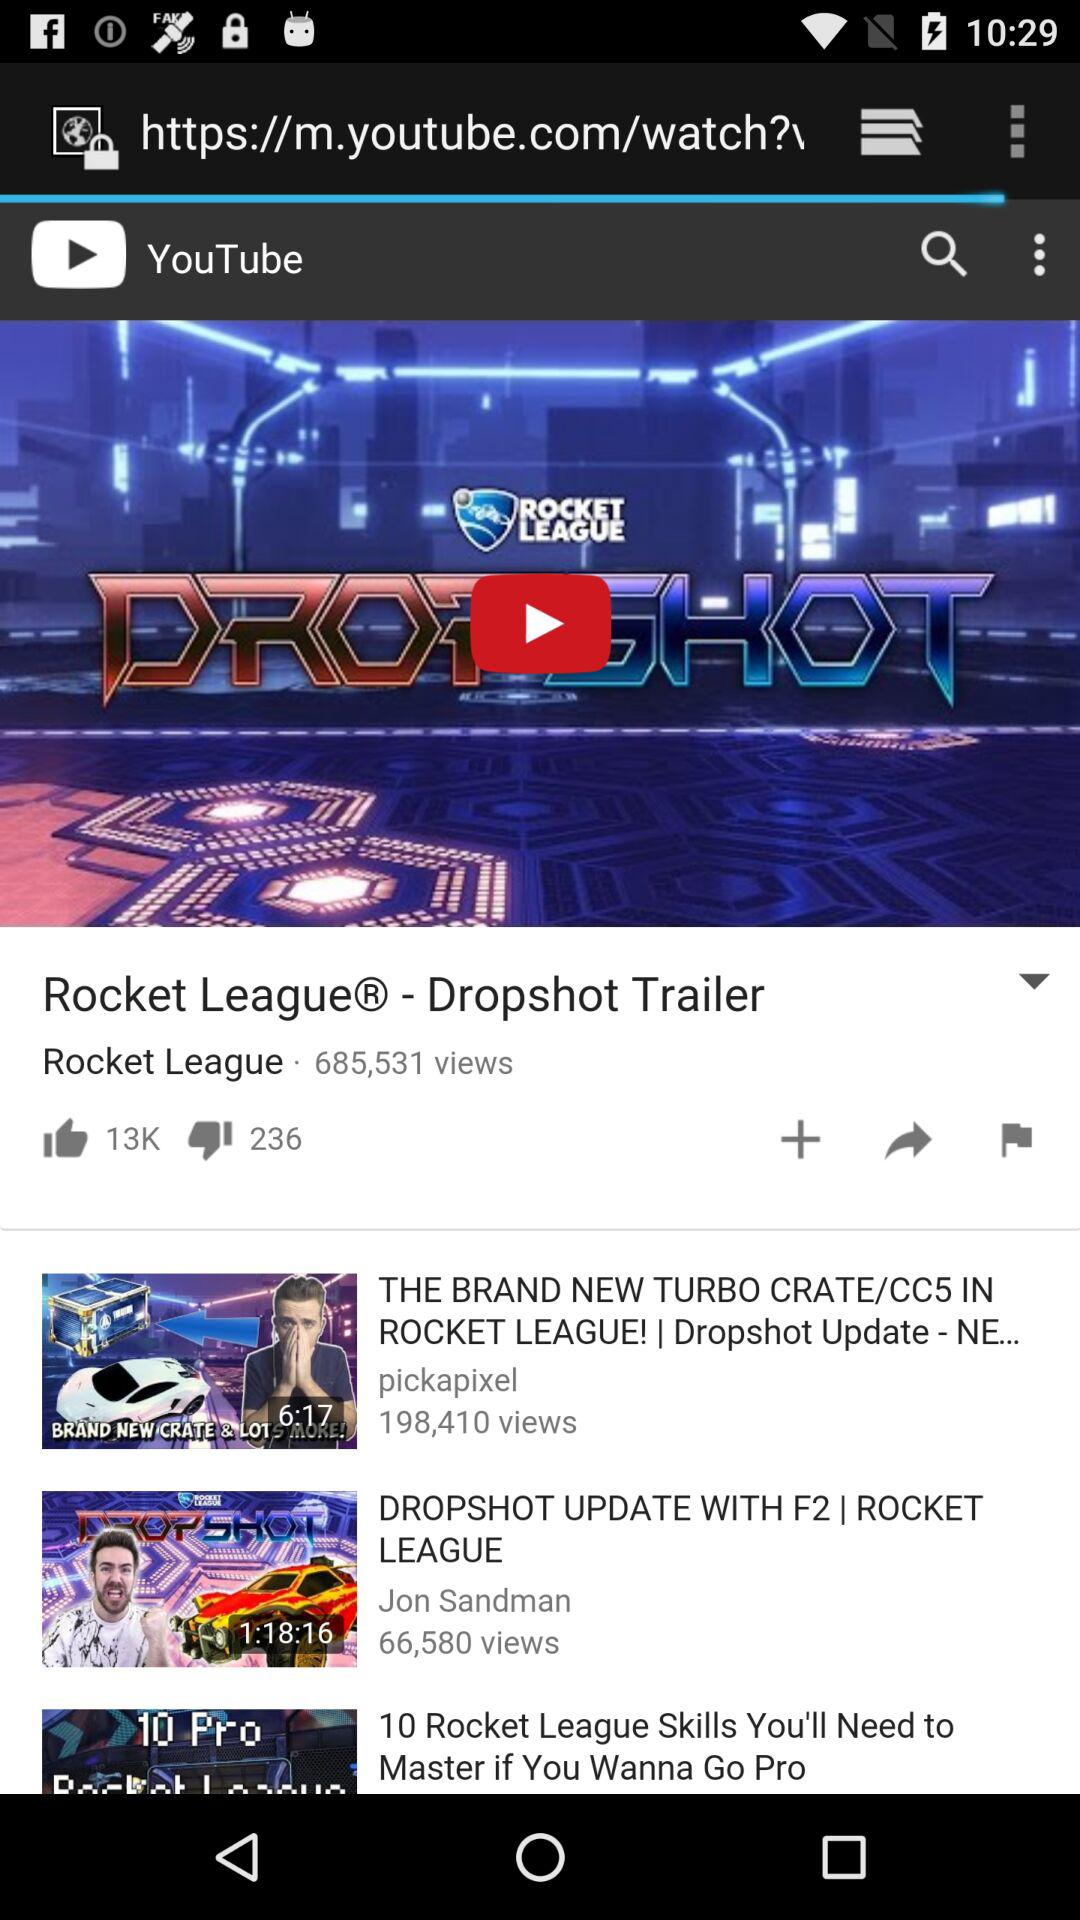How many views does the video with the most views have?
Answer the question using a single word or phrase. 685,531 